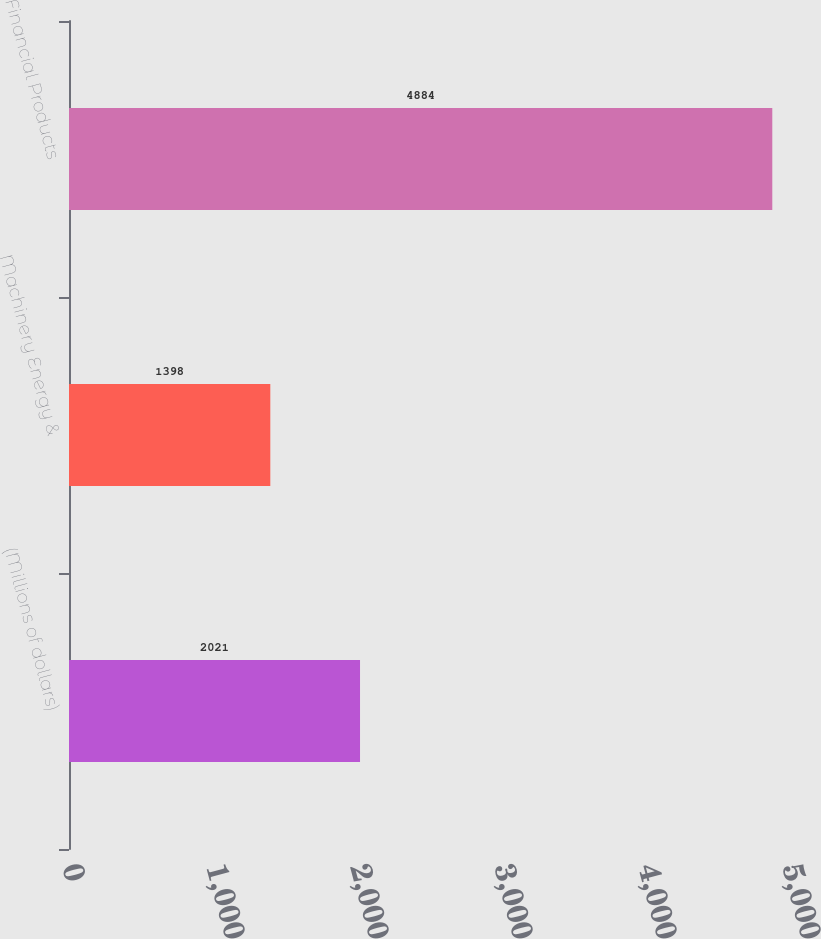<chart> <loc_0><loc_0><loc_500><loc_500><bar_chart><fcel>(Millions of dollars)<fcel>Machinery Energy &<fcel>Financial Products<nl><fcel>2021<fcel>1398<fcel>4884<nl></chart> 